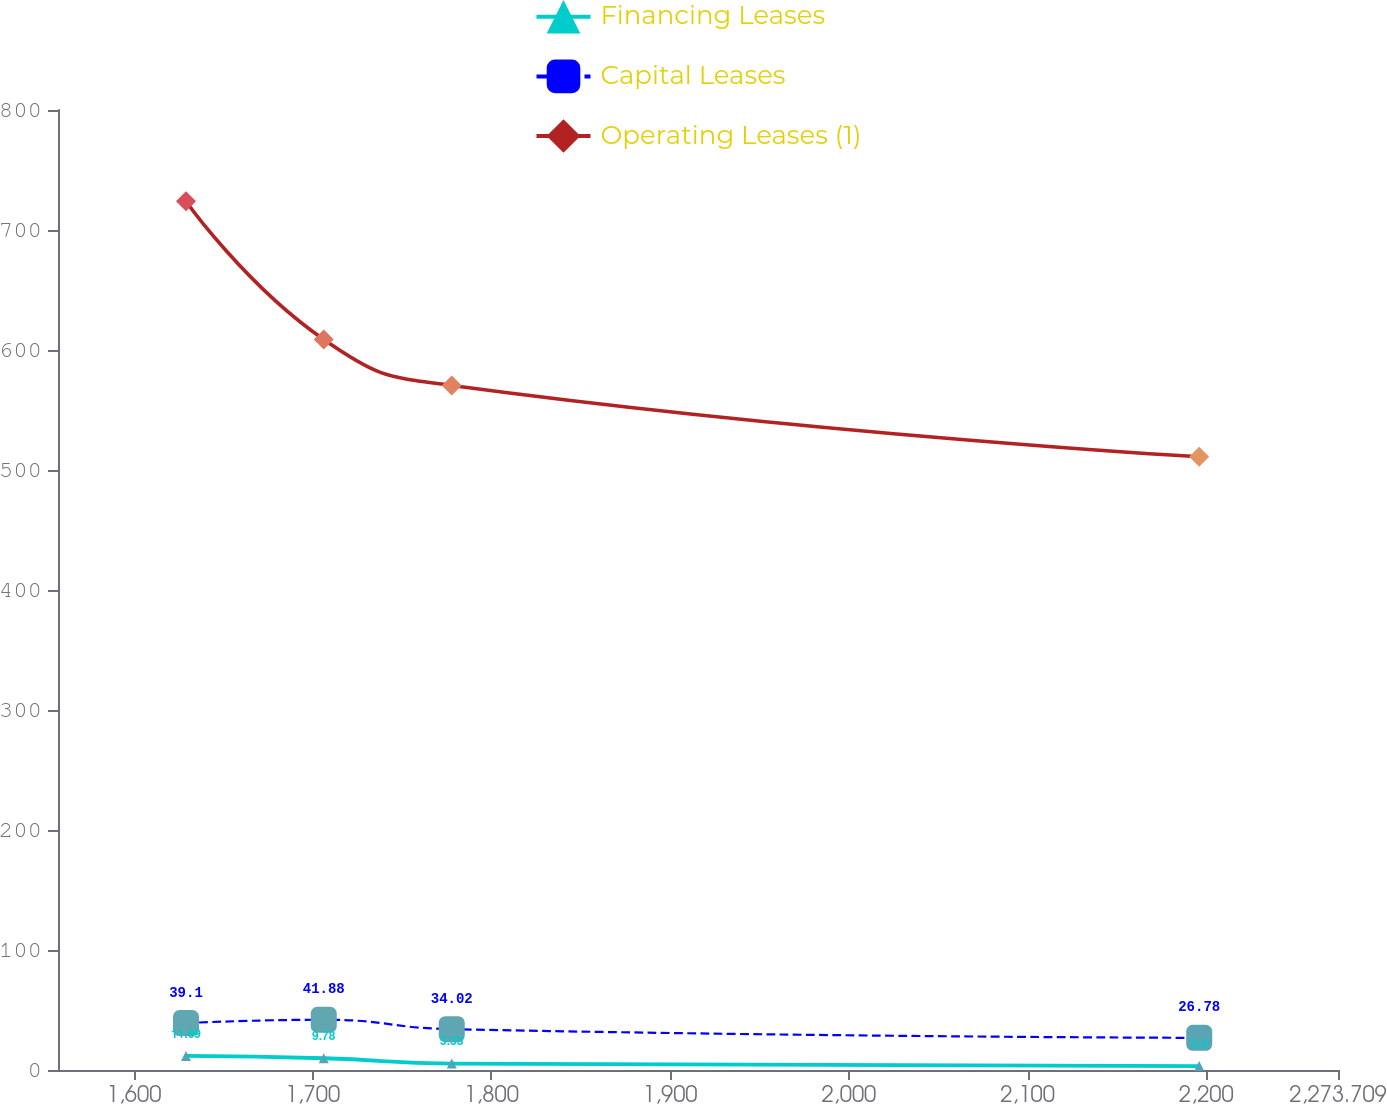Convert chart to OTSL. <chart><loc_0><loc_0><loc_500><loc_500><line_chart><ecel><fcel>Financing Leases<fcel>Capital Leases<fcel>Operating Leases (1)<nl><fcel>1629.12<fcel>11.69<fcel>39.1<fcel>723.95<nl><fcel>1706.2<fcel>9.78<fcel>41.88<fcel>608.71<nl><fcel>1777.82<fcel>5.33<fcel>34.02<fcel>570.47<nl><fcel>2196.05<fcel>3.3<fcel>26.78<fcel>510.98<nl><fcel>2345.33<fcel>2.37<fcel>14.14<fcel>341.54<nl></chart> 